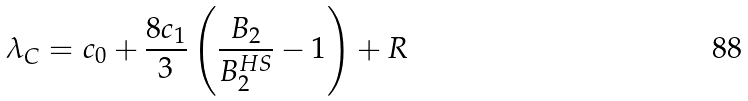Convert formula to latex. <formula><loc_0><loc_0><loc_500><loc_500>\lambda _ { C } = c _ { 0 } + \frac { 8 c _ { 1 } } { 3 } \left ( \frac { B _ { 2 } } { B _ { 2 } ^ { H S } } - 1 \right ) + R</formula> 